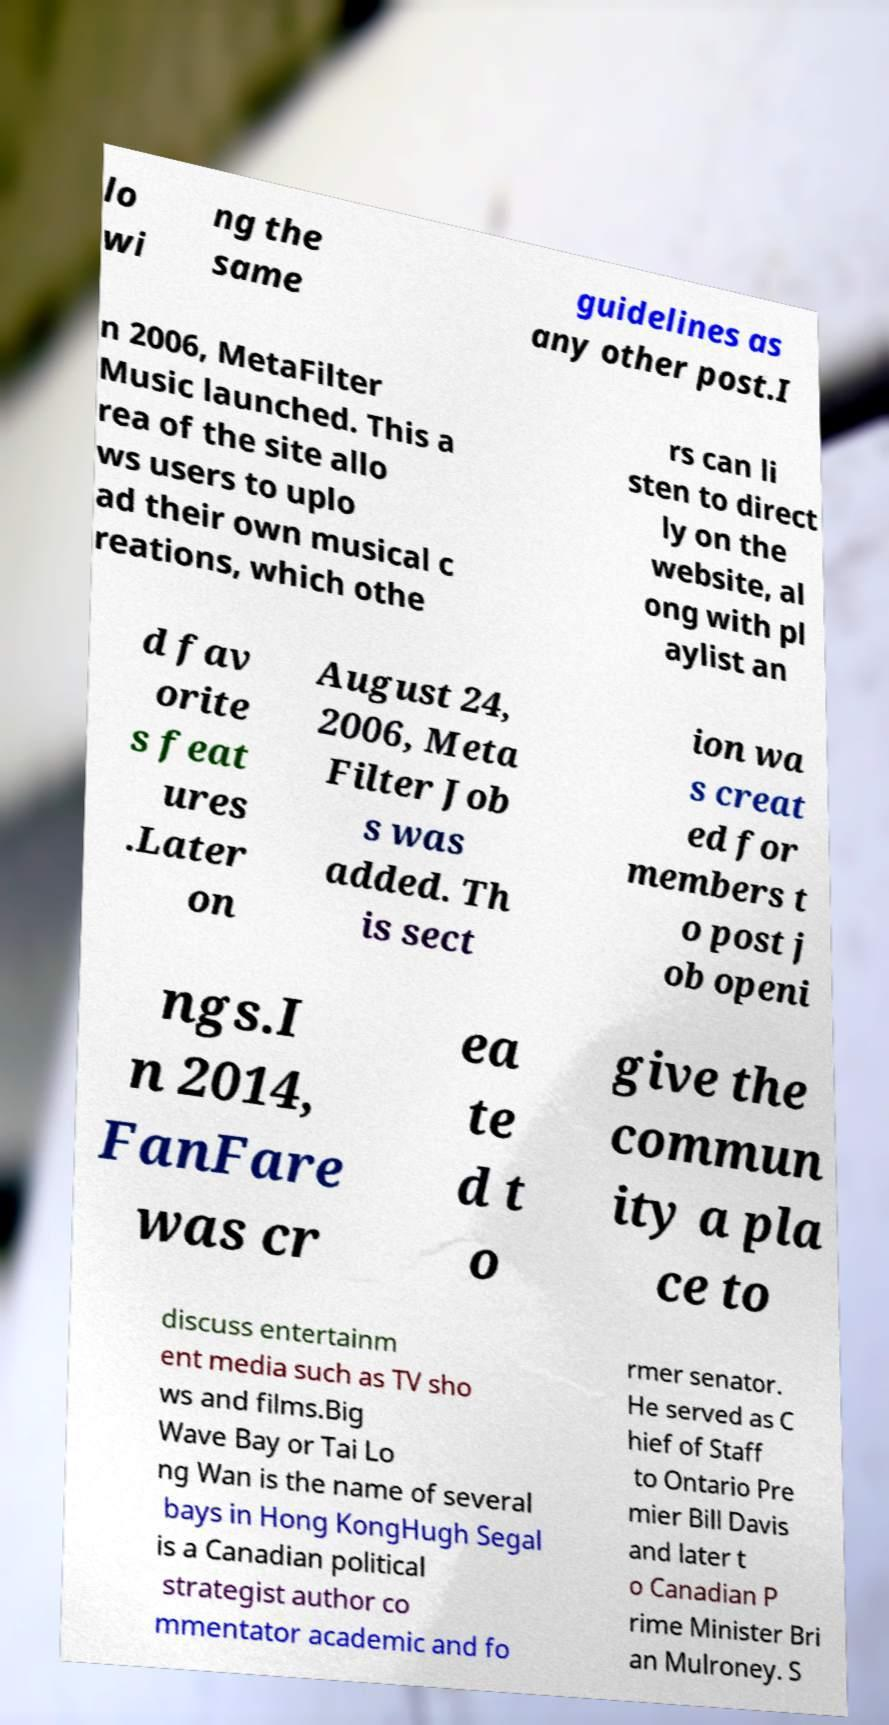Please identify and transcribe the text found in this image. lo wi ng the same guidelines as any other post.I n 2006, MetaFilter Music launched. This a rea of the site allo ws users to uplo ad their own musical c reations, which othe rs can li sten to direct ly on the website, al ong with pl aylist an d fav orite s feat ures .Later on August 24, 2006, Meta Filter Job s was added. Th is sect ion wa s creat ed for members t o post j ob openi ngs.I n 2014, FanFare was cr ea te d t o give the commun ity a pla ce to discuss entertainm ent media such as TV sho ws and films.Big Wave Bay or Tai Lo ng Wan is the name of several bays in Hong KongHugh Segal is a Canadian political strategist author co mmentator academic and fo rmer senator. He served as C hief of Staff to Ontario Pre mier Bill Davis and later t o Canadian P rime Minister Bri an Mulroney. S 